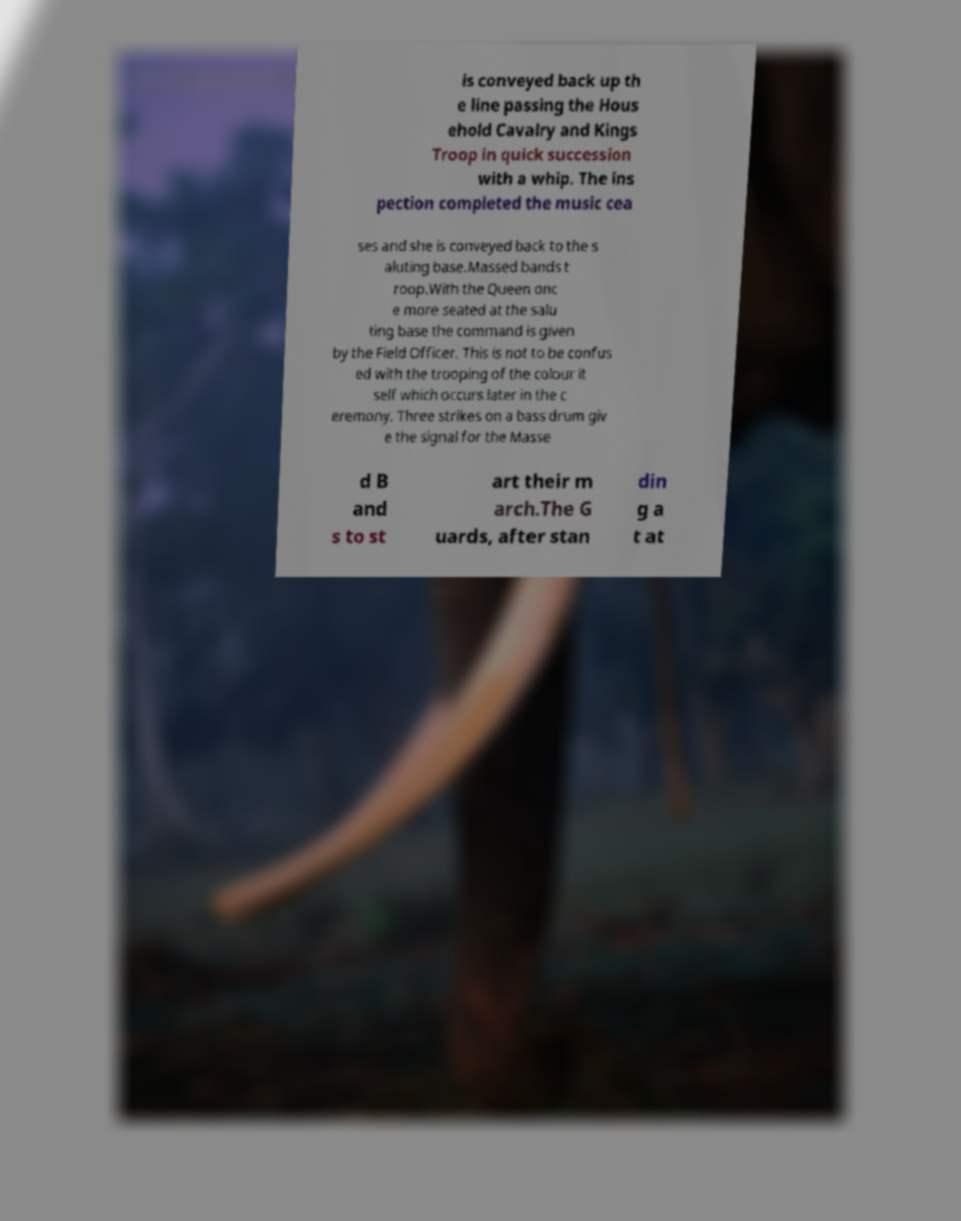Can you read and provide the text displayed in the image?This photo seems to have some interesting text. Can you extract and type it out for me? is conveyed back up th e line passing the Hous ehold Cavalry and Kings Troop in quick succession with a whip. The ins pection completed the music cea ses and she is conveyed back to the s aluting base.Massed bands t roop.With the Queen onc e more seated at the salu ting base the command is given by the Field Officer. This is not to be confus ed with the trooping of the colour it self which occurs later in the c eremony. Three strikes on a bass drum giv e the signal for the Masse d B and s to st art their m arch.The G uards, after stan din g a t at 